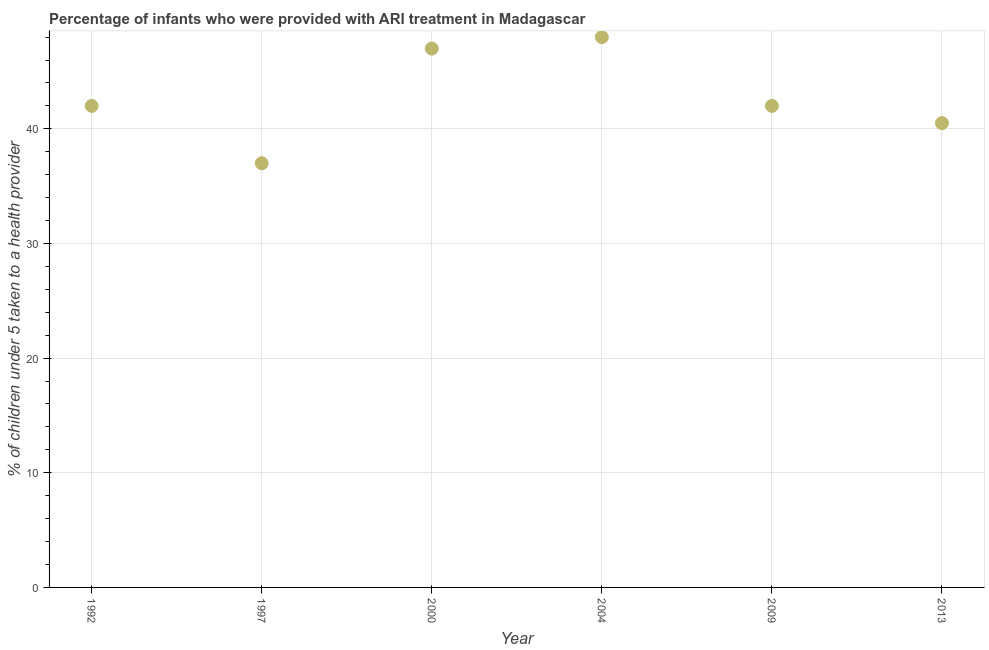What is the percentage of children who were provided with ari treatment in 2013?
Provide a short and direct response. 40.5. Across all years, what is the minimum percentage of children who were provided with ari treatment?
Your answer should be compact. 37. What is the sum of the percentage of children who were provided with ari treatment?
Ensure brevity in your answer.  256.5. What is the average percentage of children who were provided with ari treatment per year?
Provide a short and direct response. 42.75. What is the ratio of the percentage of children who were provided with ari treatment in 1992 to that in 1997?
Offer a terse response. 1.14. Is the percentage of children who were provided with ari treatment in 1992 less than that in 2000?
Offer a terse response. Yes. What is the difference between the highest and the second highest percentage of children who were provided with ari treatment?
Your response must be concise. 1. What is the difference between the highest and the lowest percentage of children who were provided with ari treatment?
Provide a short and direct response. 11. Does the percentage of children who were provided with ari treatment monotonically increase over the years?
Offer a terse response. No. How many dotlines are there?
Keep it short and to the point. 1. How many years are there in the graph?
Provide a succinct answer. 6. What is the difference between two consecutive major ticks on the Y-axis?
Ensure brevity in your answer.  10. What is the title of the graph?
Give a very brief answer. Percentage of infants who were provided with ARI treatment in Madagascar. What is the label or title of the X-axis?
Ensure brevity in your answer.  Year. What is the label or title of the Y-axis?
Your answer should be very brief. % of children under 5 taken to a health provider. What is the % of children under 5 taken to a health provider in 1992?
Your response must be concise. 42. What is the % of children under 5 taken to a health provider in 1997?
Your answer should be very brief. 37. What is the % of children under 5 taken to a health provider in 2004?
Your response must be concise. 48. What is the % of children under 5 taken to a health provider in 2013?
Give a very brief answer. 40.5. What is the difference between the % of children under 5 taken to a health provider in 1992 and 1997?
Your answer should be very brief. 5. What is the difference between the % of children under 5 taken to a health provider in 1992 and 2009?
Your response must be concise. 0. What is the difference between the % of children under 5 taken to a health provider in 1992 and 2013?
Keep it short and to the point. 1.5. What is the difference between the % of children under 5 taken to a health provider in 1997 and 2000?
Provide a succinct answer. -10. What is the difference between the % of children under 5 taken to a health provider in 2000 and 2004?
Your answer should be compact. -1. What is the difference between the % of children under 5 taken to a health provider in 2000 and 2013?
Your answer should be very brief. 6.5. What is the ratio of the % of children under 5 taken to a health provider in 1992 to that in 1997?
Make the answer very short. 1.14. What is the ratio of the % of children under 5 taken to a health provider in 1992 to that in 2000?
Your answer should be very brief. 0.89. What is the ratio of the % of children under 5 taken to a health provider in 1992 to that in 2004?
Your answer should be very brief. 0.88. What is the ratio of the % of children under 5 taken to a health provider in 1992 to that in 2009?
Your answer should be compact. 1. What is the ratio of the % of children under 5 taken to a health provider in 1997 to that in 2000?
Offer a very short reply. 0.79. What is the ratio of the % of children under 5 taken to a health provider in 1997 to that in 2004?
Make the answer very short. 0.77. What is the ratio of the % of children under 5 taken to a health provider in 1997 to that in 2009?
Keep it short and to the point. 0.88. What is the ratio of the % of children under 5 taken to a health provider in 1997 to that in 2013?
Your answer should be very brief. 0.91. What is the ratio of the % of children under 5 taken to a health provider in 2000 to that in 2009?
Provide a succinct answer. 1.12. What is the ratio of the % of children under 5 taken to a health provider in 2000 to that in 2013?
Provide a succinct answer. 1.16. What is the ratio of the % of children under 5 taken to a health provider in 2004 to that in 2009?
Ensure brevity in your answer.  1.14. What is the ratio of the % of children under 5 taken to a health provider in 2004 to that in 2013?
Offer a terse response. 1.19. What is the ratio of the % of children under 5 taken to a health provider in 2009 to that in 2013?
Make the answer very short. 1.04. 